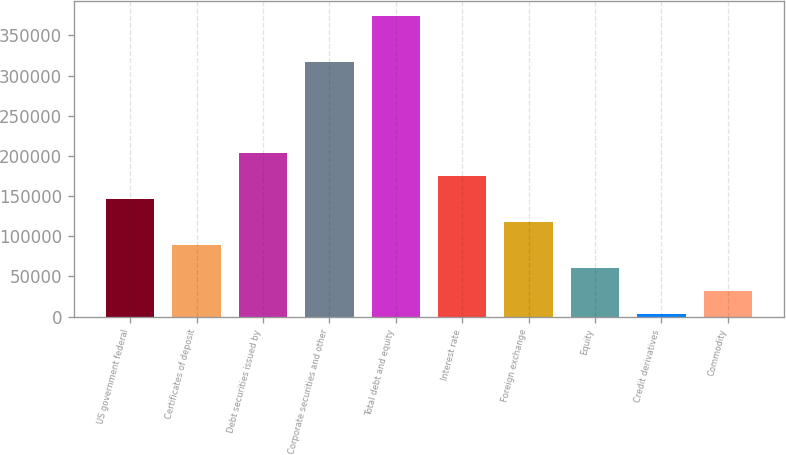Convert chart. <chart><loc_0><loc_0><loc_500><loc_500><bar_chart><fcel>US government federal<fcel>Certificates of deposit<fcel>Debt securities issued by<fcel>Corporate securities and other<fcel>Total debt and equity<fcel>Interest rate<fcel>Foreign exchange<fcel>Equity<fcel>Credit derivatives<fcel>Commodity<nl><fcel>145880<fcel>88705.7<fcel>203053<fcel>317401<fcel>374575<fcel>174466<fcel>117293<fcel>60118.8<fcel>2945<fcel>31531.9<nl></chart> 